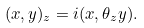<formula> <loc_0><loc_0><loc_500><loc_500>( x , y ) _ { z } = i ( x , \theta _ { z } y ) .</formula> 